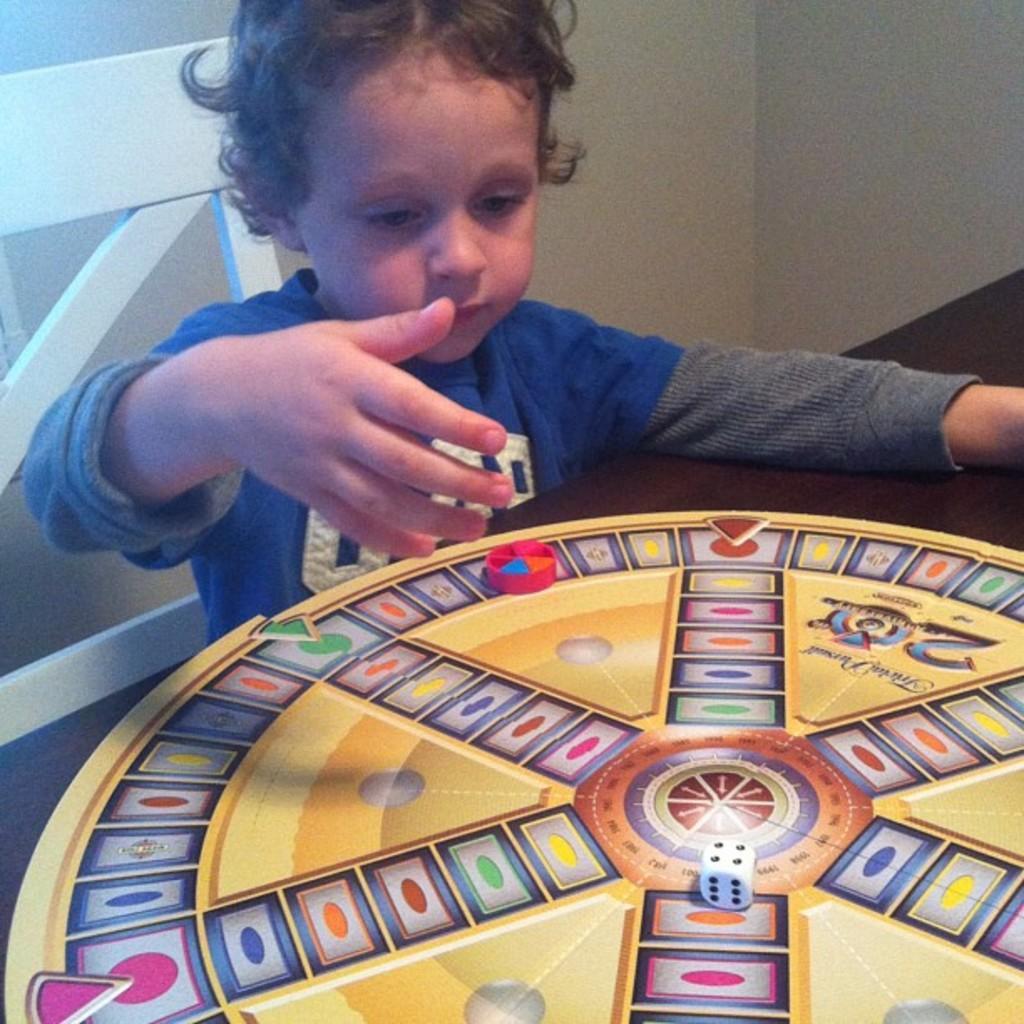Could you give a brief overview of what you see in this image? In this image we can see a game is kept on a wooden table and a child wearing blue T-shirt is sitting on the chair. In the background, we can see the wall. 